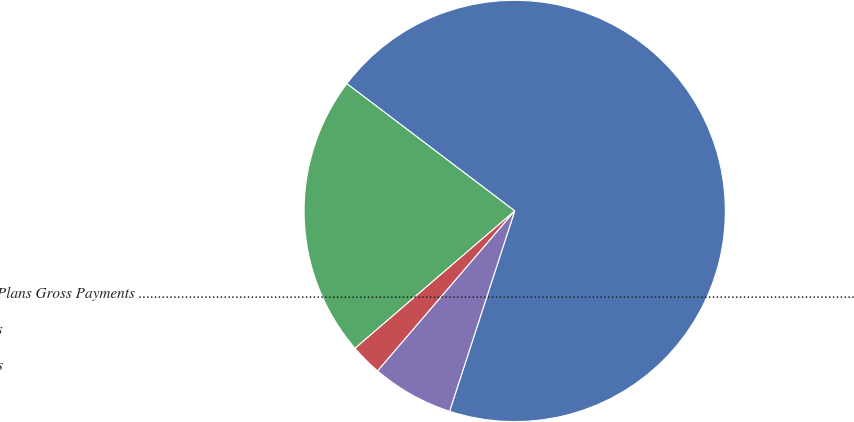Convert chart to OTSL. <chart><loc_0><loc_0><loc_500><loc_500><pie_chart><fcel>Other Postretirement Benefit Plans Gross Payments .........................................................................................................................................................................................<fcel>Postemployment Benefit Plans<fcel>Defined Benefit Pension Plans<fcel>Medicare Subsidy Receipts<nl><fcel>69.69%<fcel>21.63%<fcel>2.42%<fcel>6.27%<nl></chart> 